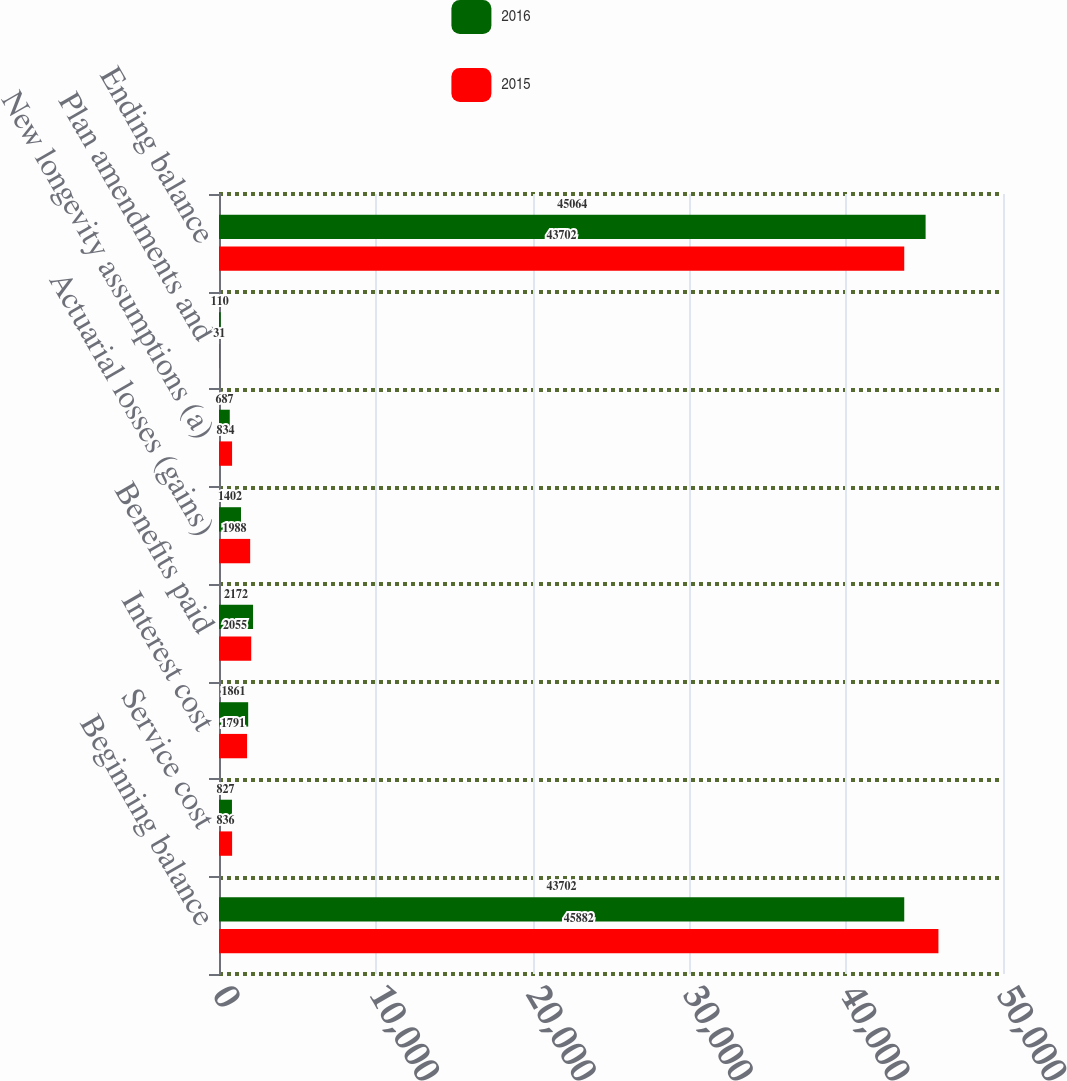Convert chart. <chart><loc_0><loc_0><loc_500><loc_500><stacked_bar_chart><ecel><fcel>Beginning balance<fcel>Service cost<fcel>Interest cost<fcel>Benefits paid<fcel>Actuarial losses (gains)<fcel>New longevity assumptions (a)<fcel>Plan amendments and<fcel>Ending balance<nl><fcel>2016<fcel>43702<fcel>827<fcel>1861<fcel>2172<fcel>1402<fcel>687<fcel>110<fcel>45064<nl><fcel>2015<fcel>45882<fcel>836<fcel>1791<fcel>2055<fcel>1988<fcel>834<fcel>31<fcel>43702<nl></chart> 